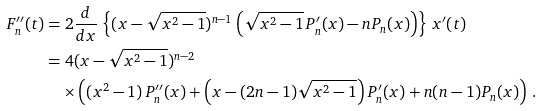<formula> <loc_0><loc_0><loc_500><loc_500>F _ { n } ^ { \prime \prime } ( t ) & = 2 \frac { d } { d x } \, \left \{ ( x - \sqrt { x ^ { 2 } - 1 } ) ^ { n - 1 } \left ( \sqrt { x ^ { 2 } - 1 } \, P _ { n } ^ { \prime } ( x ) - n P _ { n } ( x ) \right ) \right \} \, x ^ { \prime } ( t ) \\ & = 4 ( x - \sqrt { x ^ { 2 } - 1 } ) ^ { n - 2 } \\ & \quad \times \left ( ( x ^ { 2 } - 1 ) \, P _ { n } ^ { \prime \prime } ( x ) + \left ( x - ( 2 n - 1 ) \sqrt { x ^ { 2 } - 1 } \right ) P _ { n } ^ { \prime } ( x ) + n ( n - 1 ) P _ { n } ( x ) \right ) \, .</formula> 